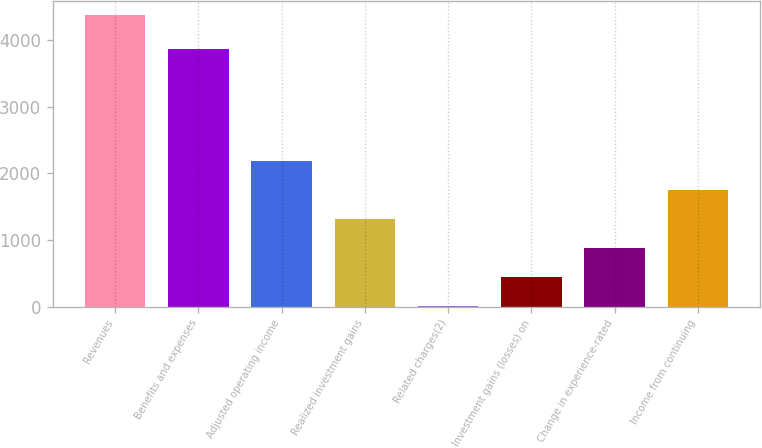<chart> <loc_0><loc_0><loc_500><loc_500><bar_chart><fcel>Revenues<fcel>Benefits and expenses<fcel>Adjusted operating income<fcel>Realized investment gains<fcel>Related charges(2)<fcel>Investment gains (losses) on<fcel>Change in experience-rated<fcel>Income from continuing<nl><fcel>4378<fcel>3869<fcel>2191.5<fcel>1316.9<fcel>5<fcel>442.3<fcel>879.6<fcel>1754.2<nl></chart> 